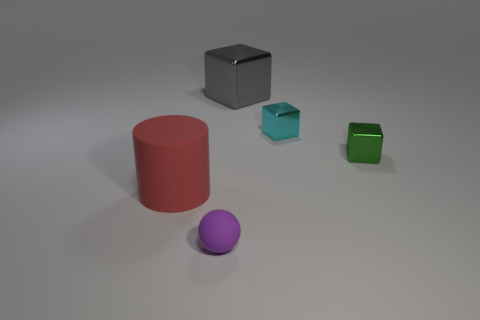Subtract all gray shiny blocks. How many blocks are left? 2 Add 2 big yellow metallic cylinders. How many objects exist? 7 Subtract all cyan cubes. How many cubes are left? 2 Subtract 3 blocks. How many blocks are left? 0 Subtract all brown cylinders. How many green cubes are left? 1 Subtract all tiny gray objects. Subtract all large red things. How many objects are left? 4 Add 2 big red cylinders. How many big red cylinders are left? 3 Add 4 cylinders. How many cylinders exist? 5 Subtract 1 purple balls. How many objects are left? 4 Subtract all cylinders. How many objects are left? 4 